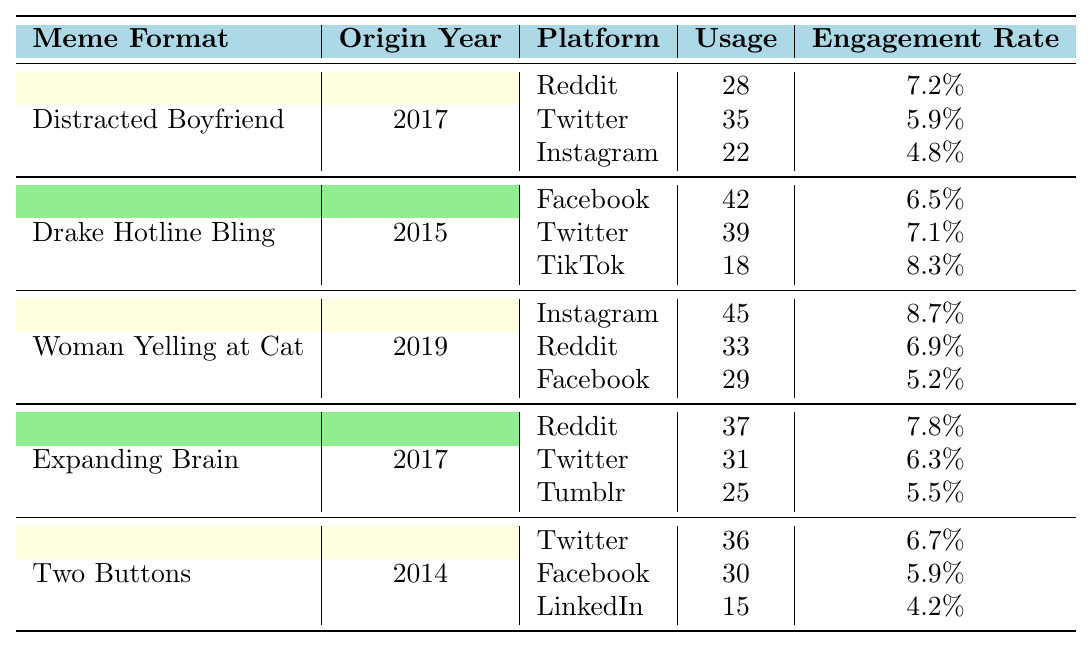What is the most used meme format on Reddit? The Usage column for Reddit shows that the "Woman Yelling at Cat" format has 33 usages, "Distracted Boyfriend" has 28, "Expanding Brain" has 37, "Drake Hotline Bling" isn't on Reddit, and "Two Buttons" has no usage listed. The highest is "Expanding Brain" with 37 usages.
Answer: Expanding Brain What is the engagement rate of the "Drake Hotline Bling" format on TikTok? From the table, the "Drake Hotline Bling" format has an engagement rate of 8.3% on TikTok, as stated in the respective row.
Answer: 8.3% Which meme format has the highest engagement rate on Instagram? The engagement rates for the formats on Instagram are as follows: "Distracted Boyfriend" (4.8%), "Woman Yelling at Cat" (8.7%), and "Drake Hotline Bling" isn't on Instagram. The highest is "Woman Yelling at Cat" with 8.7%.
Answer: Woman Yelling at Cat Calculate the total usage of the "Two Buttons" meme format across all platforms. The usage for "Two Buttons" is 36 on Twitter, 30 on Facebook, and 15 on LinkedIn. Adding these values gives: 36 + 30 + 15 = 81.
Answer: 81 Is the engagement rate of "Expanding Brain" on Twitter lower than that on Reddit? The engagement rate for "Expanding Brain" on Twitter is 6.3% while on Reddit, it is 7.8%. Since 6.3% is less than 7.8%, the statement is true.
Answer: Yes Which meme format has the highest total usage across all platforms? First, we calculate the total usage for each format: "Distracted Boyfriend" = 28 + 35 + 22 = 85, "Drake Hotline Bling" = 42 + 39 + 18 = 99, "Woman Yelling at Cat" = 45 + 33 + 29 = 107, "Expanding Brain" = 37 + 31 + 25 = 93, and "Two Buttons" = 36 + 30 + 15 = 81. The highest total is for "Woman Yelling at Cat" with 107.
Answer: Woman Yelling at Cat Which platform shows the lowest engagement rate for the "Distracted Boyfriend" meme format? For "Distracted Boyfriend," the engagement rates are 7.2% on Reddit, 5.9% on Twitter, and 4.8% on Instagram. The lowest engagement rate is therefore on Instagram.
Answer: Instagram What percentage of the engagement rate does the "Woman Yelling at Cat" meme have on Facebook contribute compared to its highest engagement rate on Instagram? The engagement rate on Facebook for "Woman Yelling at Cat" is 5.2%, and on Instagram, it is 8.7%. To find the percentage: (5.2 / 8.7) * 100 ≈ 59.77%. This means it contributes about 59.77% of the highest engagement rate.
Answer: 59.77% 